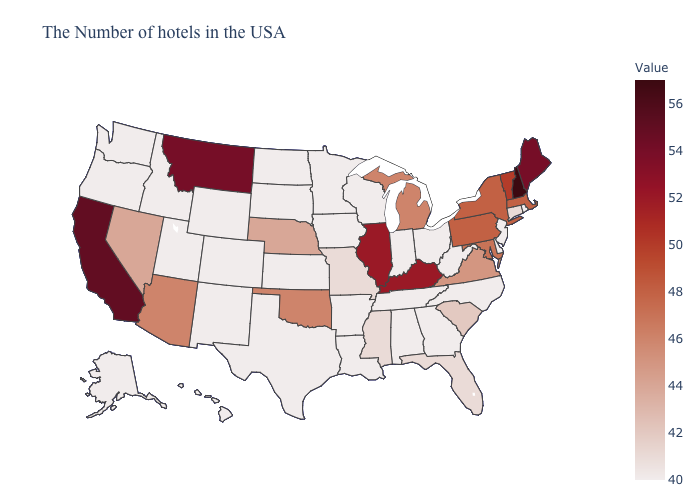Which states have the lowest value in the MidWest?
Keep it brief. Ohio, Indiana, Wisconsin, Minnesota, Iowa, Kansas, South Dakota, North Dakota. Does New Hampshire have the highest value in the USA?
Be succinct. Yes. Does North Carolina have a lower value than Pennsylvania?
Quick response, please. Yes. Among the states that border Arkansas , which have the highest value?
Give a very brief answer. Oklahoma. Does Hawaii have the lowest value in the USA?
Quick response, please. Yes. Which states have the highest value in the USA?
Keep it brief. New Hampshire. Which states have the lowest value in the USA?
Concise answer only. Rhode Island, New Jersey, Delaware, North Carolina, West Virginia, Ohio, Georgia, Indiana, Alabama, Tennessee, Wisconsin, Louisiana, Arkansas, Minnesota, Iowa, Kansas, Texas, South Dakota, North Dakota, Wyoming, Colorado, New Mexico, Utah, Idaho, Washington, Oregon, Alaska, Hawaii. 